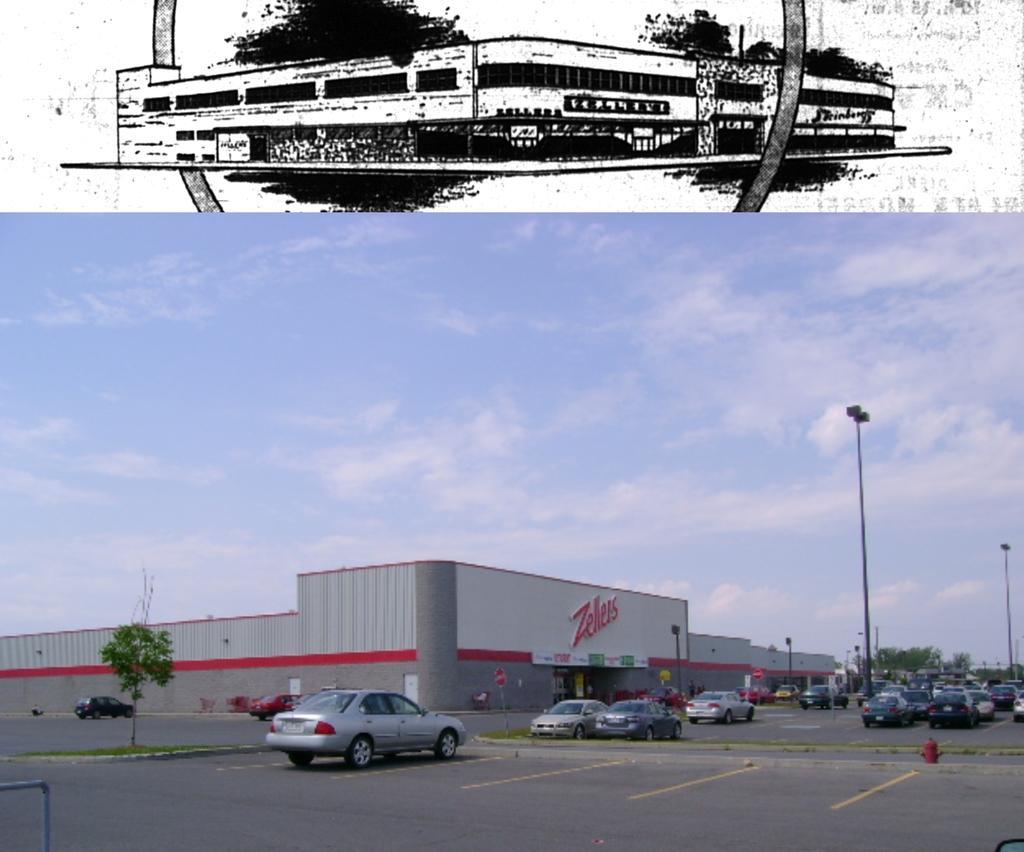Could you give a brief overview of what you see in this image? In this picture we can see a few vehicles on the road. There is a rod on the left side. We can see a glass object on the right side. There are a few poles, buildings and trees are visible in the background. Sky is blue in color and cloudy. We can see the sketch of a building on top of the picture. 